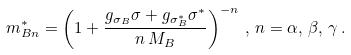Convert formula to latex. <formula><loc_0><loc_0><loc_500><loc_500>m _ { B n } ^ { \ast } = \left ( 1 + \frac { g _ { \sigma _ { B } } \sigma + g _ { \sigma ^ { \ast } _ { B } } \sigma ^ { \ast } } { n \, M _ { B } } \right ) ^ { - n } \, , \, n = \alpha , \, \beta , \, \gamma \, .</formula> 